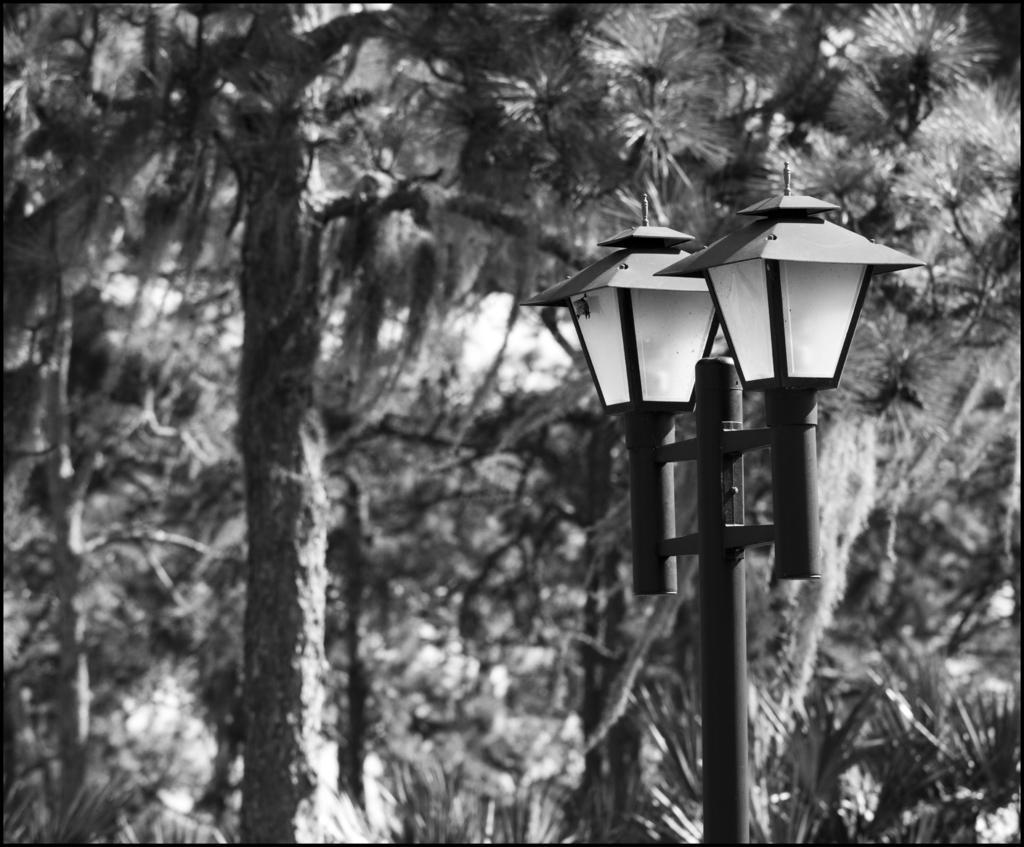In one or two sentences, can you explain what this image depicts? In this picture we can see a pole and two lights in the front, in the background there are some trees. 